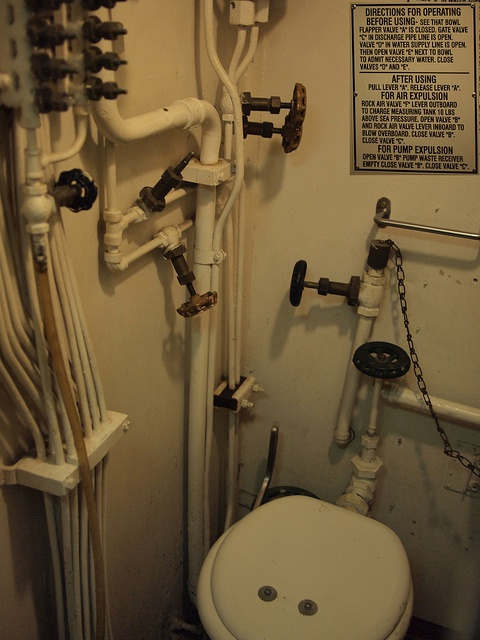Describe the objects in this image and their specific colors. I can see a toilet in black, olive, and gray tones in this image. 